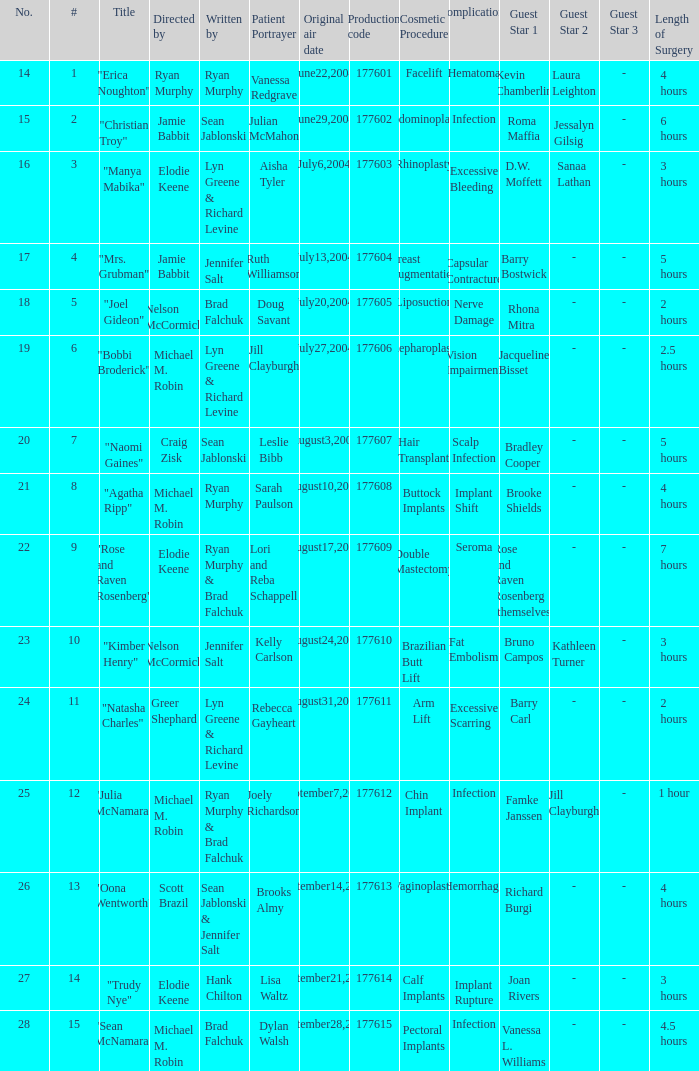What is the highest numbered episode with patient portrayer doug savant? 5.0. Parse the full table. {'header': ['No.', '#', 'Title', 'Directed by', 'Written by', 'Patient Portrayer', 'Original air date', 'Production code', 'Cosmetic Procedure', 'Complications', 'Guest Star 1', 'Guest Star 2', 'Guest Star 3', 'Length of Surgery'], 'rows': [['14', '1', '"Erica Noughton"', 'Ryan Murphy', 'Ryan Murphy', 'Vanessa Redgrave', 'June22,2004', '177601', 'Facelift', 'Hematoma', 'Kevin Chamberlin', 'Laura Leighton', '-', '4 hours'], ['15', '2', '"Christian Troy"', 'Jamie Babbit', 'Sean Jablonski', 'Julian McMahon', 'June29,2004', '177602', 'Abdominoplasty', 'Infection', 'Roma Maffia', 'Jessalyn Gilsig', '-', '6 hours'], ['16', '3', '"Manya Mabika"', 'Elodie Keene', 'Lyn Greene & Richard Levine', 'Aisha Tyler', 'July6,2004', '177603', 'Rhinoplasty', 'Excessive Bleeding', 'D.W. Moffett', 'Sanaa Lathan', '-', '3 hours'], ['17', '4', '"Mrs. Grubman"', 'Jamie Babbit', 'Jennifer Salt', 'Ruth Williamson', 'July13,2004', '177604', 'Breast Augmentation', 'Capsular Contracture', 'Barry Bostwick', '-', '-', '5 hours'], ['18', '5', '"Joel Gideon"', 'Nelson McCormick', 'Brad Falchuk', 'Doug Savant', 'July20,2004', '177605', 'Liposuction', 'Nerve Damage', 'Rhona Mitra', '-', '-', '2 hours'], ['19', '6', '"Bobbi Broderick"', 'Michael M. Robin', 'Lyn Greene & Richard Levine', 'Jill Clayburgh', 'July27,2004', '177606', 'Blepharoplasty', 'Vision Impairment', 'Jacqueline Bisset', '-', '-', '2.5 hours'], ['20', '7', '"Naomi Gaines"', 'Craig Zisk', 'Sean Jablonski', 'Leslie Bibb', 'August3,2004', '177607', 'Hair Transplant', 'Scalp Infection', 'Bradley Cooper', '-', '-', '5 hours'], ['21', '8', '"Agatha Ripp"', 'Michael M. Robin', 'Ryan Murphy', 'Sarah Paulson', 'August10,2004', '177608', 'Buttock Implants', 'Implant Shift', 'Brooke Shields', '-', '-', '4 hours'], ['22', '9', '"Rose and Raven Rosenberg"', 'Elodie Keene', 'Ryan Murphy & Brad Falchuk', 'Lori and Reba Schappell', 'August17,2004', '177609', 'Double Mastectomy', 'Seroma', 'Rose and Raven Rosenberg (themselves)', '-', '-', '7 hours'], ['23', '10', '"Kimber Henry"', 'Nelson McCormick', 'Jennifer Salt', 'Kelly Carlson', 'August24,2004', '177610', 'Brazilian Butt Lift', 'Fat Embolism', 'Bruno Campos', 'Kathleen Turner', '-', '3 hours'], ['24', '11', '"Natasha Charles"', 'Greer Shephard', 'Lyn Greene & Richard Levine', 'Rebecca Gayheart', 'August31,2004', '177611', 'Arm Lift', 'Excessive Scarring', 'Barry Carl', '-', '-', '2 hours'], ['25', '12', '"Julia McNamara"', 'Michael M. Robin', 'Ryan Murphy & Brad Falchuk', 'Joely Richardson', 'September7,2004', '177612', 'Chin Implant', 'Infection', 'Famke Janssen', 'Jill Clayburgh', '-', '1 hour'], ['26', '13', '"Oona Wentworth"', 'Scott Brazil', 'Sean Jablonski & Jennifer Salt', 'Brooks Almy', 'September14,2004', '177613', 'Vaginoplasty', 'Hemorrhage', 'Richard Burgi', '-', '-', '4 hours'], ['27', '14', '"Trudy Nye"', 'Elodie Keene', 'Hank Chilton', 'Lisa Waltz', 'September21,2004', '177614', 'Calf Implants', 'Implant Rupture', 'Joan Rivers', '-', '-', '3 hours'], ['28', '15', '"Sean McNamara"', 'Michael M. Robin', 'Brad Falchuk', 'Dylan Walsh', 'September28,2004', '177615', 'Pectoral Implants', 'Infection', 'Vanessa L. Williams', '-', '-', '4.5 hours']]} 